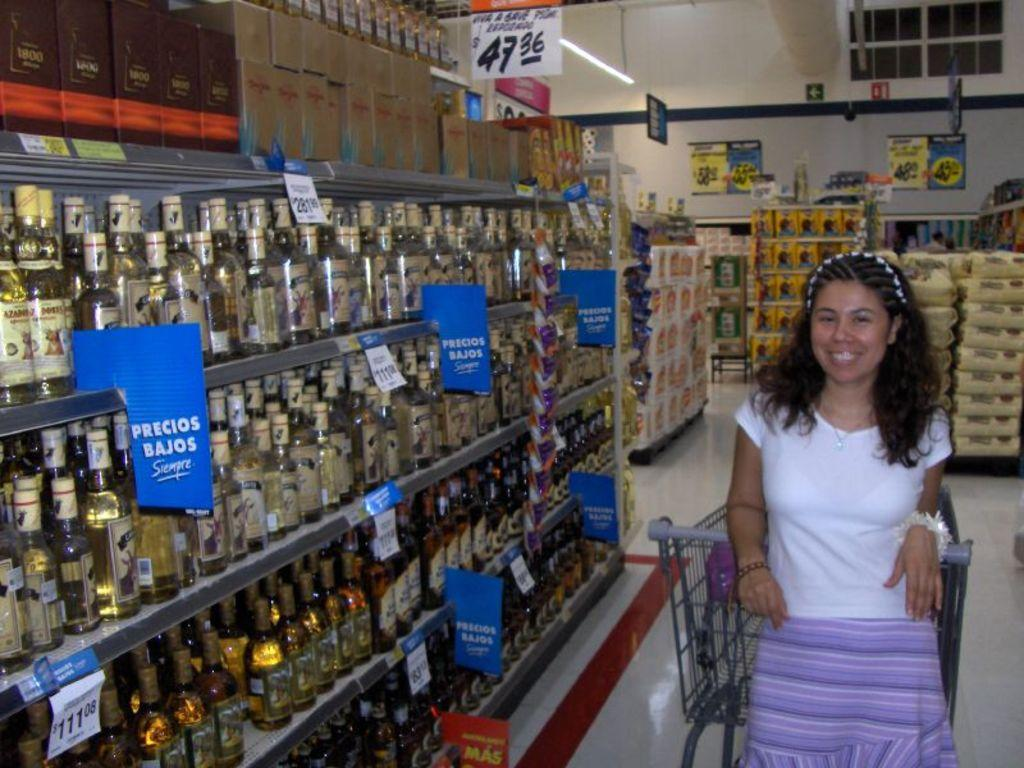Who is the main subject in the image? There is a lady in the image. What is the lady doing in the image? The lady is standing and smiling. What can be seen in the background of the image? There are bottles and boxes on a shelf in the background. What other object is present in the image? There is a trolley in the image. How many icicles are hanging from the lady's hair in the image? There are no icicles present in the image. What is the lady's attention focused on in the image? The image does not provide information about the lady's attention or focus. 